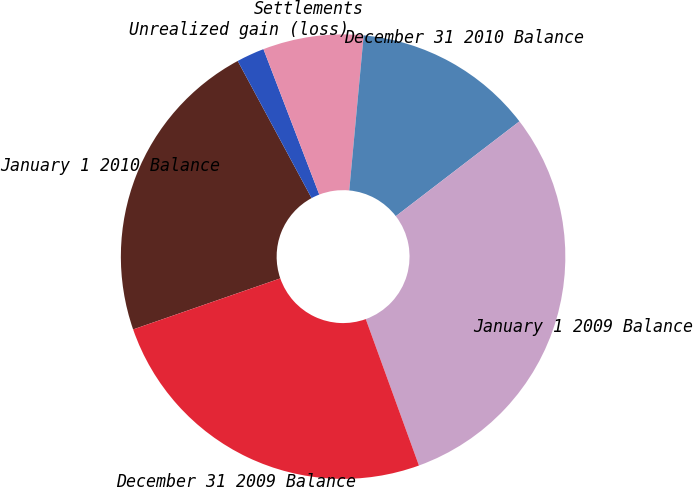Convert chart to OTSL. <chart><loc_0><loc_0><loc_500><loc_500><pie_chart><fcel>January 1 2010 Balance<fcel>Unrealized gain (loss)<fcel>Settlements<fcel>December 31 2010 Balance<fcel>January 1 2009 Balance<fcel>December 31 2009 Balance<nl><fcel>22.45%<fcel>2.03%<fcel>7.31%<fcel>13.11%<fcel>29.87%<fcel>25.23%<nl></chart> 